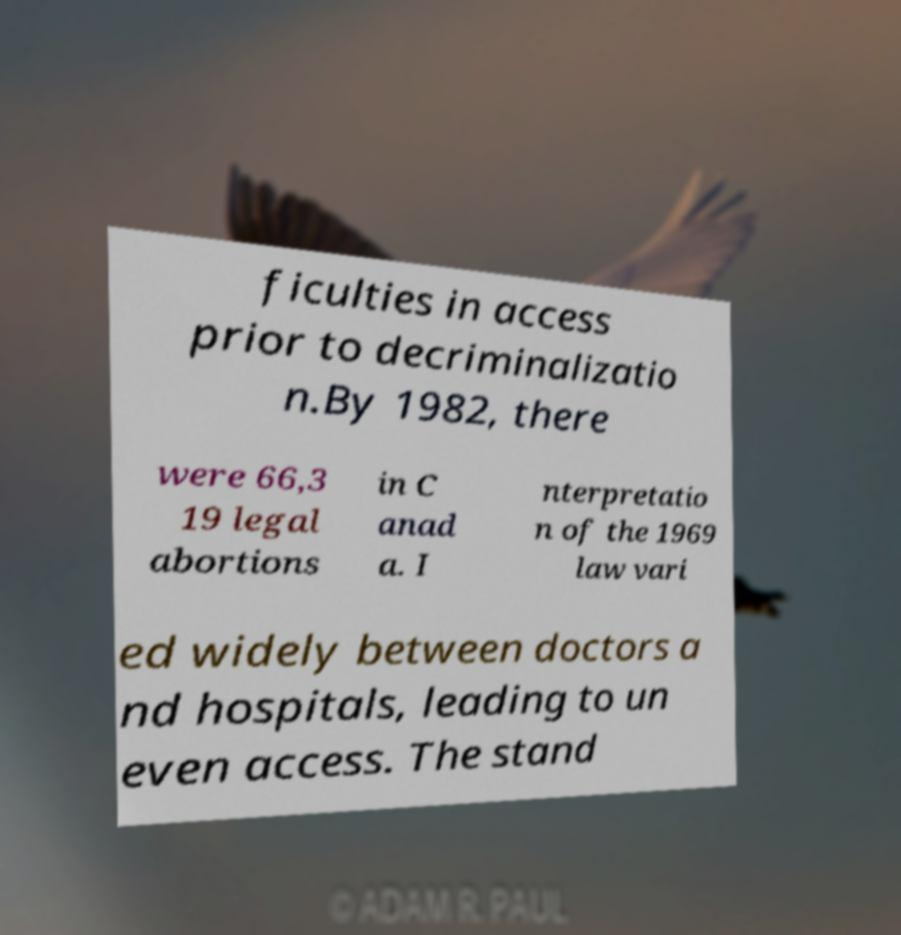I need the written content from this picture converted into text. Can you do that? ficulties in access prior to decriminalizatio n.By 1982, there were 66,3 19 legal abortions in C anad a. I nterpretatio n of the 1969 law vari ed widely between doctors a nd hospitals, leading to un even access. The stand 